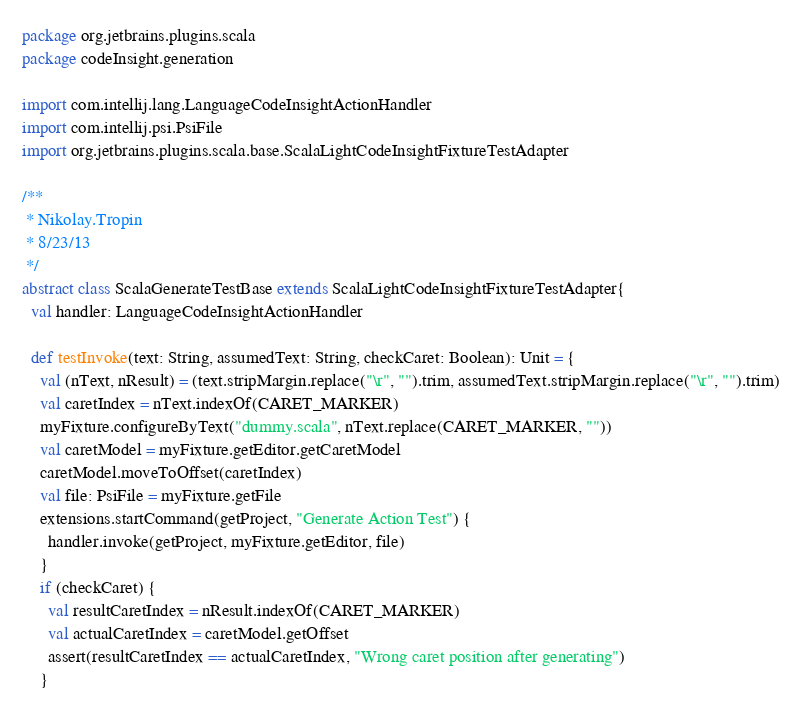Convert code to text. <code><loc_0><loc_0><loc_500><loc_500><_Scala_>package org.jetbrains.plugins.scala
package codeInsight.generation

import com.intellij.lang.LanguageCodeInsightActionHandler
import com.intellij.psi.PsiFile
import org.jetbrains.plugins.scala.base.ScalaLightCodeInsightFixtureTestAdapter

/**
 * Nikolay.Tropin
 * 8/23/13
 */
abstract class ScalaGenerateTestBase extends ScalaLightCodeInsightFixtureTestAdapter{
  val handler: LanguageCodeInsightActionHandler

  def testInvoke(text: String, assumedText: String, checkCaret: Boolean): Unit = {
    val (nText, nResult) = (text.stripMargin.replace("\r", "").trim, assumedText.stripMargin.replace("\r", "").trim)
    val caretIndex = nText.indexOf(CARET_MARKER)
    myFixture.configureByText("dummy.scala", nText.replace(CARET_MARKER, ""))
    val caretModel = myFixture.getEditor.getCaretModel
    caretModel.moveToOffset(caretIndex)
    val file: PsiFile = myFixture.getFile
    extensions.startCommand(getProject, "Generate Action Test") {
      handler.invoke(getProject, myFixture.getEditor, file)
    }
    if (checkCaret) {
      val resultCaretIndex = nResult.indexOf(CARET_MARKER)
      val actualCaretIndex = caretModel.getOffset
      assert(resultCaretIndex == actualCaretIndex, "Wrong caret position after generating")
    }</code> 